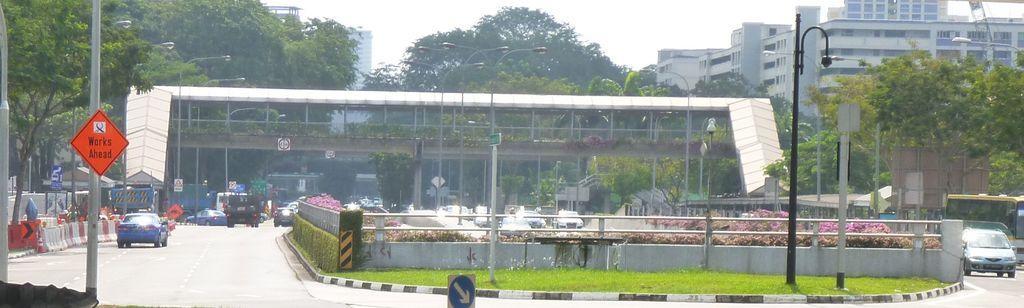Can you describe this image briefly? In this picture there is a outside area of the mall. In the front there are some cars on the road. In the center there is a fencing railing and some red color caution poles. Behind there is a glass building and some huge trees in the background. On the right side we can see the building and some trees. 